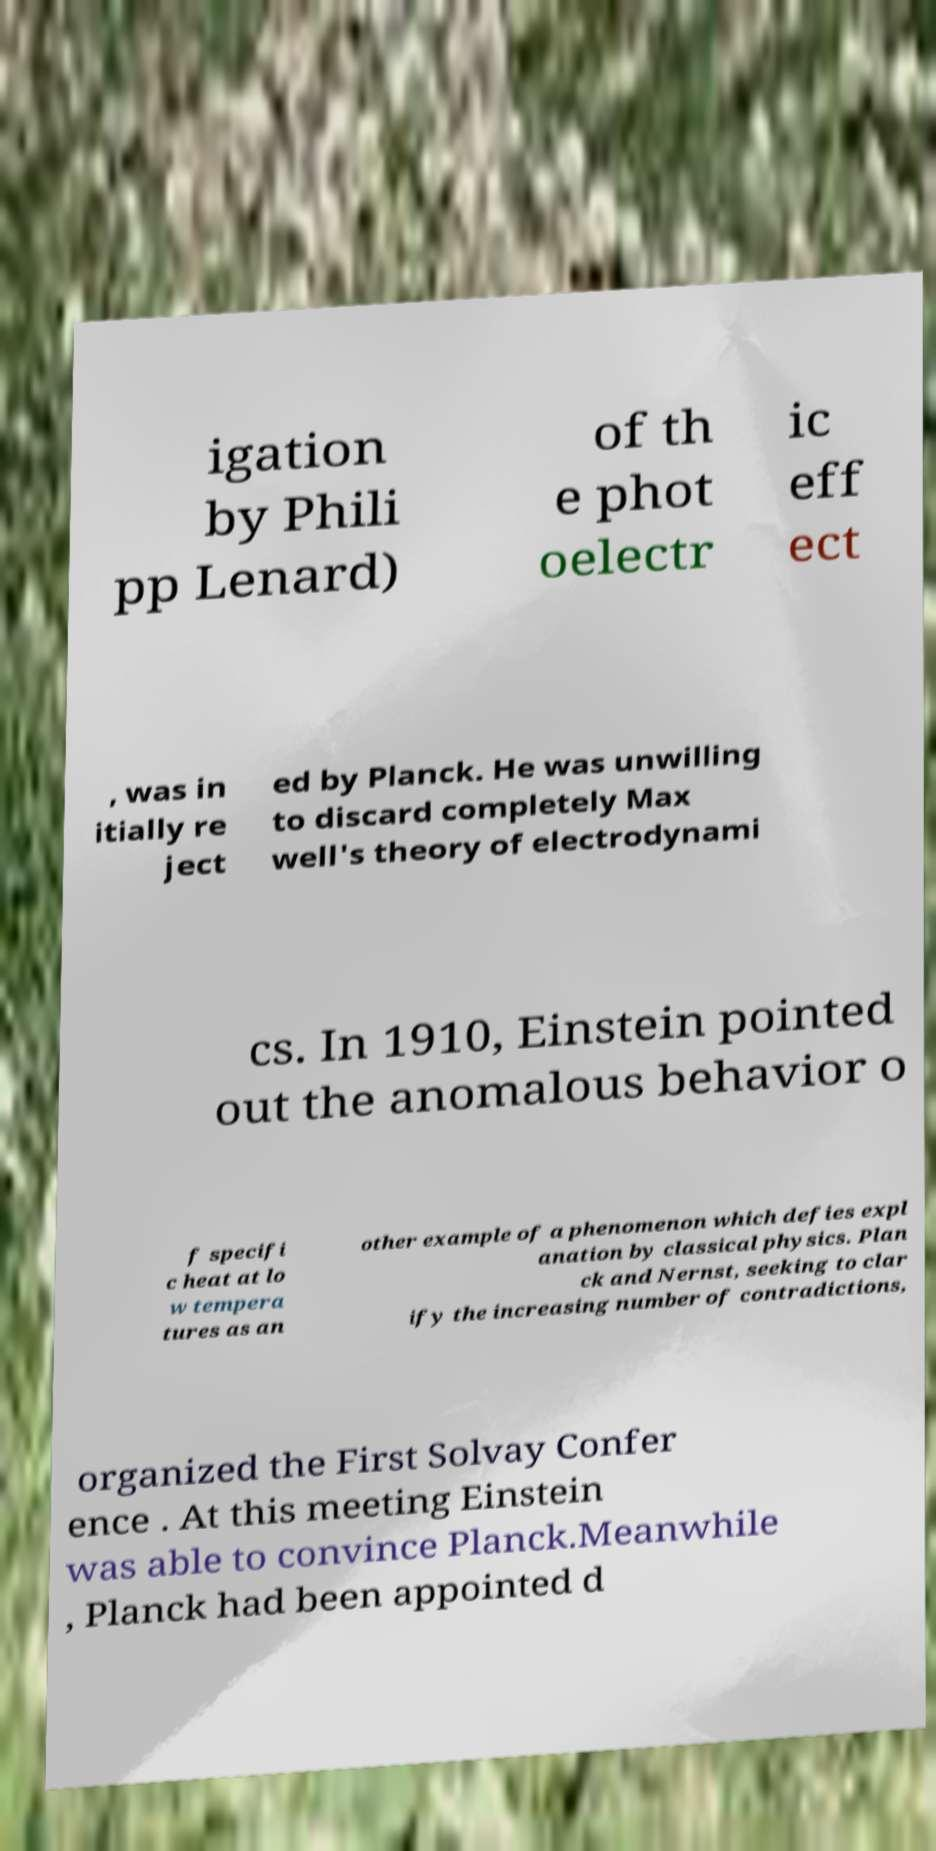I need the written content from this picture converted into text. Can you do that? igation by Phili pp Lenard) of th e phot oelectr ic eff ect , was in itially re ject ed by Planck. He was unwilling to discard completely Max well's theory of electrodynami cs. In 1910, Einstein pointed out the anomalous behavior o f specifi c heat at lo w tempera tures as an other example of a phenomenon which defies expl anation by classical physics. Plan ck and Nernst, seeking to clar ify the increasing number of contradictions, organized the First Solvay Confer ence . At this meeting Einstein was able to convince Planck.Meanwhile , Planck had been appointed d 